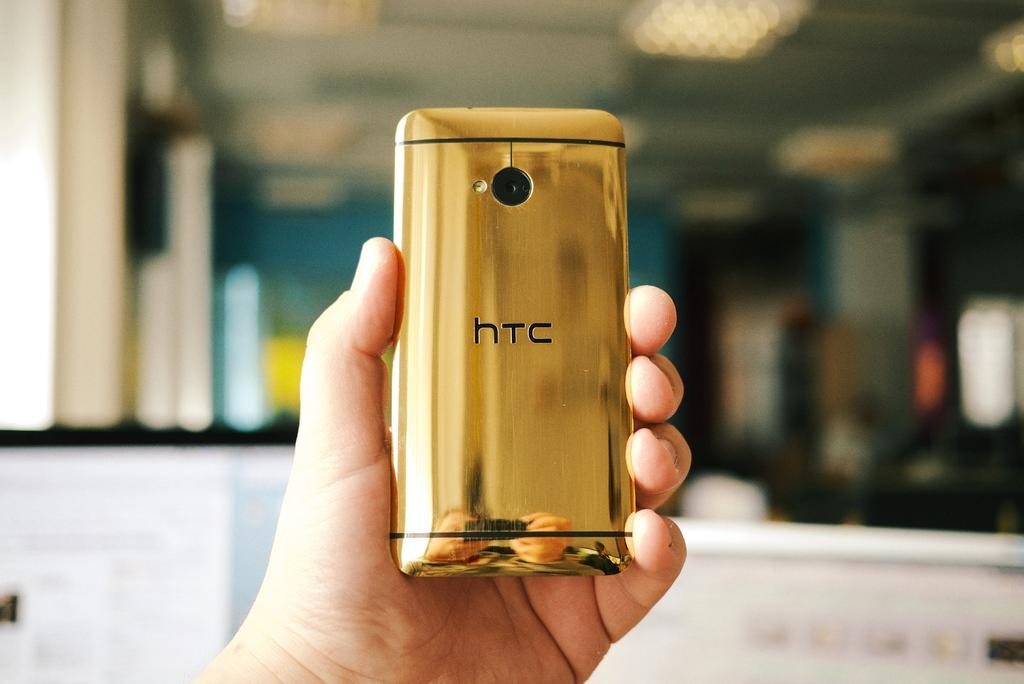What is the main subject of the image? The main subject of the image is a human hand holding a mobile. Can you describe the background of the image? The background of the image is blurry. What type of stitch is being used to repair the brick in the image? There is no brick or stitching present in the image; it features a human hand holding a mobile. How many horses are pulling the carriage in the image? There is no carriage or horses present in the image. 